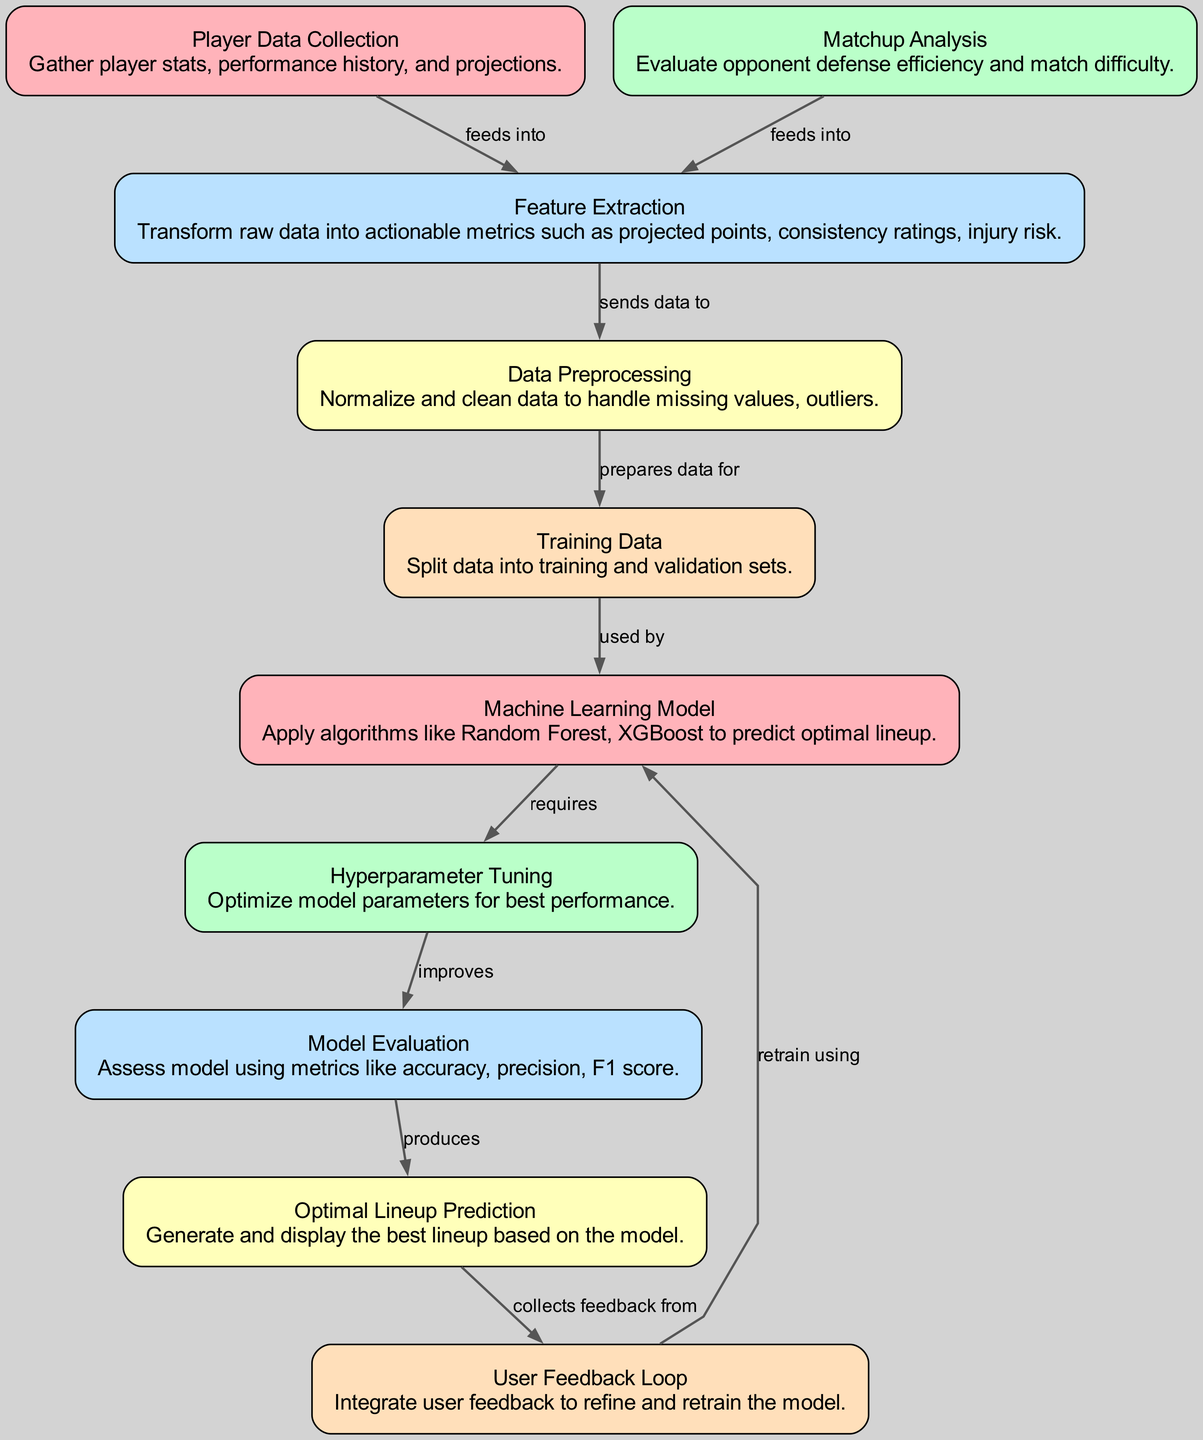What is the first step in the diagram? The first step is represented by the node labeled "Player Data Collection," which describes the gathering of player stats, performance history, and projections.
Answer: Player Data Collection How many nodes are present in the diagram? By counting each labeled node in the diagram, there are 10 nodes total representing different stages of the optimal lineup selection process.
Answer: 10 Which node sends data to Data Preprocessing? The node "Feature Extraction" is responsible for sending data to the "Data Preprocessing" node after transforming raw data into actionable metrics.
Answer: Feature Extraction What is the purpose of the User Feedback Loop? The "User Feedback Loop" collects feedback from the "Optimal Lineup Prediction" to refine and retrain the machine learning model based on user inputs and experiences.
Answer: Collect feedback from How does the Machine Learning Model improve its performance? The "Machine Learning Model" requires "Hyperparameter Tuning" to optimize its parameters, which subsequently improves the model's performance in making lineup predictions.
Answer: Hyperparameter Tuning What metrics are used for Model Evaluation? The "Model Evaluation" node assesses the machine learning model using metrics like accuracy, precision, and F1 score to determine its effectiveness.
Answer: Accuracy, precision, F1 score Which nodes are directly connected to the Optimal Lineup Prediction node? The "Model Evaluation" node produces the "Optimal Lineup Prediction," and the "User Feedback Loop" collects feedback from it, creating direct connections to both.
Answer: Model Evaluation, User Feedback Loop What type of algorithms does the Machine Learning Model apply? The "Machine Learning Model" applies algorithms such as Random Forest and XGBoost to predict the optimal fantasy football lineup based on the processed data.
Answer: Random Forest, XGBoost What is the final outcome of this diagram? The final outcome is represented by the "Optimal Lineup Prediction," which generates and displays the best lineup based on the model's predictions.
Answer: Optimal Lineup Prediction 